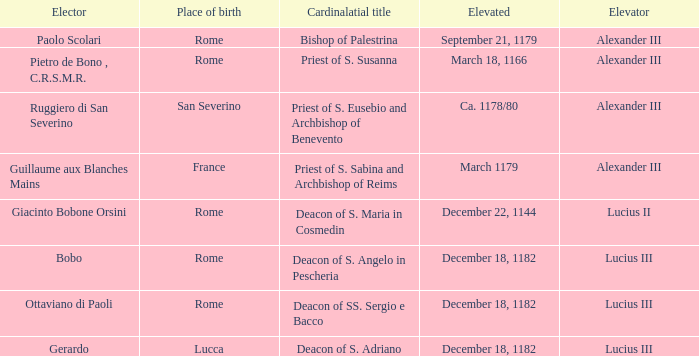On september 21, 1179, what was the condition of the elevator belonging to the elected elevated? Alexander III. 